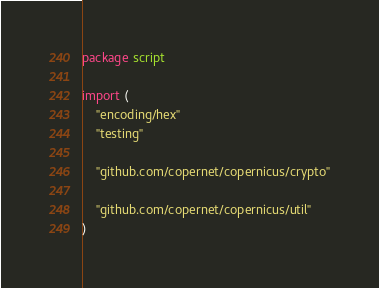Convert code to text. <code><loc_0><loc_0><loc_500><loc_500><_Go_>package script

import (
	"encoding/hex"
	"testing"

	"github.com/copernet/copernicus/crypto"

	"github.com/copernet/copernicus/util"
)
</code> 